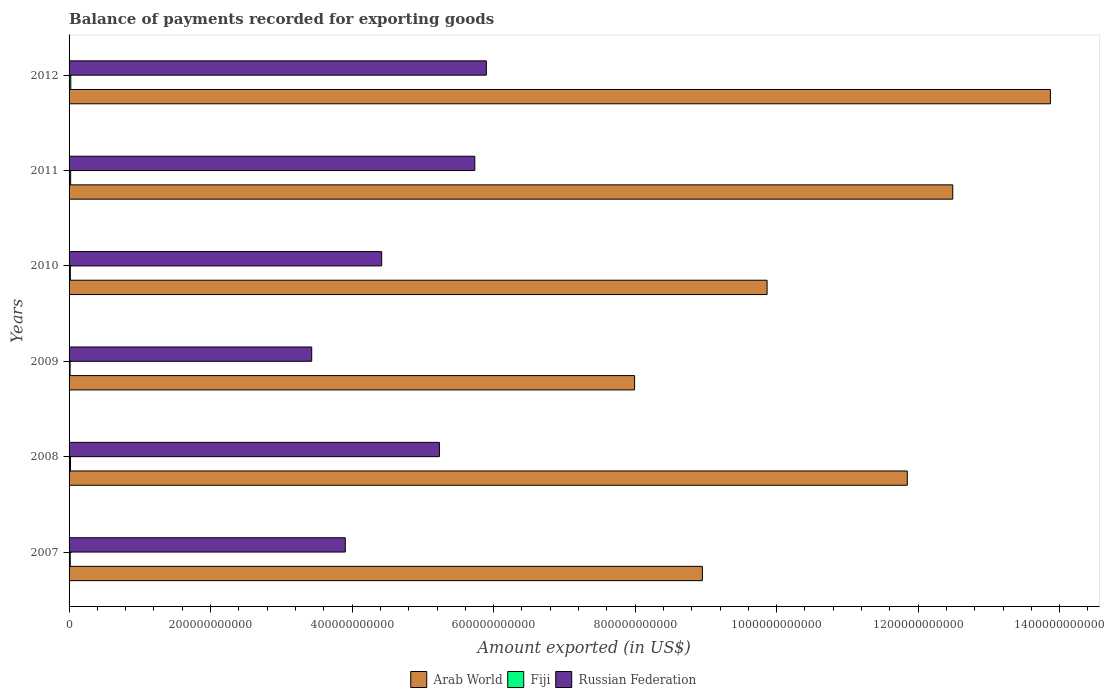How many different coloured bars are there?
Ensure brevity in your answer.  3. How many bars are there on the 5th tick from the bottom?
Offer a very short reply. 3. What is the label of the 2nd group of bars from the top?
Give a very brief answer. 2011. What is the amount exported in Russian Federation in 2011?
Ensure brevity in your answer.  5.73e+11. Across all years, what is the maximum amount exported in Arab World?
Your answer should be compact. 1.39e+12. Across all years, what is the minimum amount exported in Russian Federation?
Offer a very short reply. 3.43e+11. What is the total amount exported in Arab World in the graph?
Offer a terse response. 6.50e+12. What is the difference between the amount exported in Arab World in 2008 and that in 2010?
Your answer should be very brief. 1.98e+11. What is the difference between the amount exported in Fiji in 2011 and the amount exported in Russian Federation in 2008?
Make the answer very short. -5.21e+11. What is the average amount exported in Arab World per year?
Your answer should be very brief. 1.08e+12. In the year 2010, what is the difference between the amount exported in Arab World and amount exported in Russian Federation?
Your answer should be very brief. 5.45e+11. In how many years, is the amount exported in Fiji greater than 280000000000 US$?
Your answer should be very brief. 0. What is the ratio of the amount exported in Arab World in 2009 to that in 2010?
Provide a succinct answer. 0.81. Is the amount exported in Fiji in 2007 less than that in 2010?
Your answer should be very brief. Yes. What is the difference between the highest and the second highest amount exported in Fiji?
Offer a terse response. 2.04e+08. What is the difference between the highest and the lowest amount exported in Russian Federation?
Provide a succinct answer. 2.47e+11. Is the sum of the amount exported in Arab World in 2009 and 2012 greater than the maximum amount exported in Russian Federation across all years?
Provide a short and direct response. Yes. What does the 1st bar from the top in 2011 represents?
Your response must be concise. Russian Federation. What does the 3rd bar from the bottom in 2010 represents?
Your response must be concise. Russian Federation. Are all the bars in the graph horizontal?
Your response must be concise. Yes. How many years are there in the graph?
Give a very brief answer. 6. What is the difference between two consecutive major ticks on the X-axis?
Your answer should be compact. 2.00e+11. Are the values on the major ticks of X-axis written in scientific E-notation?
Make the answer very short. No. What is the title of the graph?
Offer a terse response. Balance of payments recorded for exporting goods. What is the label or title of the X-axis?
Provide a short and direct response. Amount exported (in US$). What is the Amount exported (in US$) in Arab World in 2007?
Offer a terse response. 8.95e+11. What is the Amount exported (in US$) of Fiji in 2007?
Provide a short and direct response. 1.65e+09. What is the Amount exported (in US$) in Russian Federation in 2007?
Ensure brevity in your answer.  3.90e+11. What is the Amount exported (in US$) in Arab World in 2008?
Provide a short and direct response. 1.18e+12. What is the Amount exported (in US$) of Fiji in 2008?
Provide a short and direct response. 2.02e+09. What is the Amount exported (in US$) in Russian Federation in 2008?
Keep it short and to the point. 5.23e+11. What is the Amount exported (in US$) of Arab World in 2009?
Ensure brevity in your answer.  7.99e+11. What is the Amount exported (in US$) in Fiji in 2009?
Your answer should be very brief. 1.42e+09. What is the Amount exported (in US$) of Russian Federation in 2009?
Give a very brief answer. 3.43e+11. What is the Amount exported (in US$) in Arab World in 2010?
Ensure brevity in your answer.  9.87e+11. What is the Amount exported (in US$) of Fiji in 2010?
Keep it short and to the point. 1.82e+09. What is the Amount exported (in US$) in Russian Federation in 2010?
Provide a succinct answer. 4.42e+11. What is the Amount exported (in US$) of Arab World in 2011?
Your response must be concise. 1.25e+12. What is the Amount exported (in US$) of Fiji in 2011?
Your answer should be very brief. 2.23e+09. What is the Amount exported (in US$) of Russian Federation in 2011?
Offer a terse response. 5.73e+11. What is the Amount exported (in US$) in Arab World in 2012?
Make the answer very short. 1.39e+12. What is the Amount exported (in US$) in Fiji in 2012?
Ensure brevity in your answer.  2.44e+09. What is the Amount exported (in US$) in Russian Federation in 2012?
Offer a terse response. 5.90e+11. Across all years, what is the maximum Amount exported (in US$) in Arab World?
Give a very brief answer. 1.39e+12. Across all years, what is the maximum Amount exported (in US$) in Fiji?
Your answer should be very brief. 2.44e+09. Across all years, what is the maximum Amount exported (in US$) in Russian Federation?
Your response must be concise. 5.90e+11. Across all years, what is the minimum Amount exported (in US$) of Arab World?
Give a very brief answer. 7.99e+11. Across all years, what is the minimum Amount exported (in US$) in Fiji?
Your answer should be compact. 1.42e+09. Across all years, what is the minimum Amount exported (in US$) in Russian Federation?
Keep it short and to the point. 3.43e+11. What is the total Amount exported (in US$) of Arab World in the graph?
Offer a very short reply. 6.50e+12. What is the total Amount exported (in US$) of Fiji in the graph?
Make the answer very short. 1.16e+1. What is the total Amount exported (in US$) in Russian Federation in the graph?
Keep it short and to the point. 2.86e+12. What is the difference between the Amount exported (in US$) of Arab World in 2007 and that in 2008?
Offer a very short reply. -2.90e+11. What is the difference between the Amount exported (in US$) in Fiji in 2007 and that in 2008?
Give a very brief answer. -3.68e+08. What is the difference between the Amount exported (in US$) of Russian Federation in 2007 and that in 2008?
Provide a succinct answer. -1.33e+11. What is the difference between the Amount exported (in US$) in Arab World in 2007 and that in 2009?
Offer a terse response. 9.59e+1. What is the difference between the Amount exported (in US$) of Fiji in 2007 and that in 2009?
Make the answer very short. 2.28e+08. What is the difference between the Amount exported (in US$) in Russian Federation in 2007 and that in 2009?
Offer a terse response. 4.74e+1. What is the difference between the Amount exported (in US$) of Arab World in 2007 and that in 2010?
Ensure brevity in your answer.  -9.14e+1. What is the difference between the Amount exported (in US$) of Fiji in 2007 and that in 2010?
Give a very brief answer. -1.70e+08. What is the difference between the Amount exported (in US$) of Russian Federation in 2007 and that in 2010?
Your answer should be very brief. -5.14e+1. What is the difference between the Amount exported (in US$) of Arab World in 2007 and that in 2011?
Provide a short and direct response. -3.54e+11. What is the difference between the Amount exported (in US$) of Fiji in 2007 and that in 2011?
Give a very brief answer. -5.82e+08. What is the difference between the Amount exported (in US$) in Russian Federation in 2007 and that in 2011?
Your answer should be very brief. -1.83e+11. What is the difference between the Amount exported (in US$) in Arab World in 2007 and that in 2012?
Provide a succinct answer. -4.92e+11. What is the difference between the Amount exported (in US$) in Fiji in 2007 and that in 2012?
Give a very brief answer. -7.86e+08. What is the difference between the Amount exported (in US$) in Russian Federation in 2007 and that in 2012?
Give a very brief answer. -1.99e+11. What is the difference between the Amount exported (in US$) of Arab World in 2008 and that in 2009?
Your response must be concise. 3.85e+11. What is the difference between the Amount exported (in US$) of Fiji in 2008 and that in 2009?
Your answer should be compact. 5.96e+08. What is the difference between the Amount exported (in US$) in Russian Federation in 2008 and that in 2009?
Keep it short and to the point. 1.80e+11. What is the difference between the Amount exported (in US$) of Arab World in 2008 and that in 2010?
Give a very brief answer. 1.98e+11. What is the difference between the Amount exported (in US$) in Fiji in 2008 and that in 2010?
Your answer should be very brief. 1.98e+08. What is the difference between the Amount exported (in US$) in Russian Federation in 2008 and that in 2010?
Provide a short and direct response. 8.16e+1. What is the difference between the Amount exported (in US$) in Arab World in 2008 and that in 2011?
Your response must be concise. -6.42e+1. What is the difference between the Amount exported (in US$) of Fiji in 2008 and that in 2011?
Give a very brief answer. -2.14e+08. What is the difference between the Amount exported (in US$) in Russian Federation in 2008 and that in 2011?
Your response must be concise. -5.00e+1. What is the difference between the Amount exported (in US$) in Arab World in 2008 and that in 2012?
Your answer should be compact. -2.02e+11. What is the difference between the Amount exported (in US$) in Fiji in 2008 and that in 2012?
Give a very brief answer. -4.18e+08. What is the difference between the Amount exported (in US$) of Russian Federation in 2008 and that in 2012?
Your response must be concise. -6.63e+1. What is the difference between the Amount exported (in US$) in Arab World in 2009 and that in 2010?
Your response must be concise. -1.87e+11. What is the difference between the Amount exported (in US$) of Fiji in 2009 and that in 2010?
Ensure brevity in your answer.  -3.98e+08. What is the difference between the Amount exported (in US$) of Russian Federation in 2009 and that in 2010?
Give a very brief answer. -9.89e+1. What is the difference between the Amount exported (in US$) in Arab World in 2009 and that in 2011?
Give a very brief answer. -4.50e+11. What is the difference between the Amount exported (in US$) of Fiji in 2009 and that in 2011?
Make the answer very short. -8.10e+08. What is the difference between the Amount exported (in US$) of Russian Federation in 2009 and that in 2011?
Your response must be concise. -2.30e+11. What is the difference between the Amount exported (in US$) in Arab World in 2009 and that in 2012?
Your answer should be very brief. -5.88e+11. What is the difference between the Amount exported (in US$) of Fiji in 2009 and that in 2012?
Offer a very short reply. -1.01e+09. What is the difference between the Amount exported (in US$) of Russian Federation in 2009 and that in 2012?
Keep it short and to the point. -2.47e+11. What is the difference between the Amount exported (in US$) of Arab World in 2010 and that in 2011?
Your answer should be compact. -2.62e+11. What is the difference between the Amount exported (in US$) in Fiji in 2010 and that in 2011?
Ensure brevity in your answer.  -4.11e+08. What is the difference between the Amount exported (in US$) of Russian Federation in 2010 and that in 2011?
Keep it short and to the point. -1.32e+11. What is the difference between the Amount exported (in US$) in Arab World in 2010 and that in 2012?
Your answer should be very brief. -4.00e+11. What is the difference between the Amount exported (in US$) of Fiji in 2010 and that in 2012?
Provide a succinct answer. -6.15e+08. What is the difference between the Amount exported (in US$) in Russian Federation in 2010 and that in 2012?
Offer a terse response. -1.48e+11. What is the difference between the Amount exported (in US$) in Arab World in 2011 and that in 2012?
Offer a very short reply. -1.38e+11. What is the difference between the Amount exported (in US$) in Fiji in 2011 and that in 2012?
Provide a short and direct response. -2.04e+08. What is the difference between the Amount exported (in US$) in Russian Federation in 2011 and that in 2012?
Provide a short and direct response. -1.63e+1. What is the difference between the Amount exported (in US$) of Arab World in 2007 and the Amount exported (in US$) of Fiji in 2008?
Your answer should be very brief. 8.93e+11. What is the difference between the Amount exported (in US$) of Arab World in 2007 and the Amount exported (in US$) of Russian Federation in 2008?
Make the answer very short. 3.72e+11. What is the difference between the Amount exported (in US$) in Fiji in 2007 and the Amount exported (in US$) in Russian Federation in 2008?
Offer a very short reply. -5.22e+11. What is the difference between the Amount exported (in US$) in Arab World in 2007 and the Amount exported (in US$) in Fiji in 2009?
Your response must be concise. 8.94e+11. What is the difference between the Amount exported (in US$) in Arab World in 2007 and the Amount exported (in US$) in Russian Federation in 2009?
Provide a succinct answer. 5.52e+11. What is the difference between the Amount exported (in US$) of Fiji in 2007 and the Amount exported (in US$) of Russian Federation in 2009?
Make the answer very short. -3.41e+11. What is the difference between the Amount exported (in US$) of Arab World in 2007 and the Amount exported (in US$) of Fiji in 2010?
Keep it short and to the point. 8.93e+11. What is the difference between the Amount exported (in US$) in Arab World in 2007 and the Amount exported (in US$) in Russian Federation in 2010?
Ensure brevity in your answer.  4.53e+11. What is the difference between the Amount exported (in US$) in Fiji in 2007 and the Amount exported (in US$) in Russian Federation in 2010?
Your response must be concise. -4.40e+11. What is the difference between the Amount exported (in US$) of Arab World in 2007 and the Amount exported (in US$) of Fiji in 2011?
Your response must be concise. 8.93e+11. What is the difference between the Amount exported (in US$) in Arab World in 2007 and the Amount exported (in US$) in Russian Federation in 2011?
Provide a succinct answer. 3.22e+11. What is the difference between the Amount exported (in US$) in Fiji in 2007 and the Amount exported (in US$) in Russian Federation in 2011?
Make the answer very short. -5.72e+11. What is the difference between the Amount exported (in US$) of Arab World in 2007 and the Amount exported (in US$) of Fiji in 2012?
Provide a short and direct response. 8.93e+11. What is the difference between the Amount exported (in US$) in Arab World in 2007 and the Amount exported (in US$) in Russian Federation in 2012?
Offer a terse response. 3.05e+11. What is the difference between the Amount exported (in US$) in Fiji in 2007 and the Amount exported (in US$) in Russian Federation in 2012?
Offer a very short reply. -5.88e+11. What is the difference between the Amount exported (in US$) of Arab World in 2008 and the Amount exported (in US$) of Fiji in 2009?
Make the answer very short. 1.18e+12. What is the difference between the Amount exported (in US$) of Arab World in 2008 and the Amount exported (in US$) of Russian Federation in 2009?
Provide a short and direct response. 8.42e+11. What is the difference between the Amount exported (in US$) of Fiji in 2008 and the Amount exported (in US$) of Russian Federation in 2009?
Provide a short and direct response. -3.41e+11. What is the difference between the Amount exported (in US$) of Arab World in 2008 and the Amount exported (in US$) of Fiji in 2010?
Your answer should be compact. 1.18e+12. What is the difference between the Amount exported (in US$) in Arab World in 2008 and the Amount exported (in US$) in Russian Federation in 2010?
Ensure brevity in your answer.  7.43e+11. What is the difference between the Amount exported (in US$) of Fiji in 2008 and the Amount exported (in US$) of Russian Federation in 2010?
Your answer should be compact. -4.40e+11. What is the difference between the Amount exported (in US$) in Arab World in 2008 and the Amount exported (in US$) in Fiji in 2011?
Make the answer very short. 1.18e+12. What is the difference between the Amount exported (in US$) in Arab World in 2008 and the Amount exported (in US$) in Russian Federation in 2011?
Offer a very short reply. 6.11e+11. What is the difference between the Amount exported (in US$) in Fiji in 2008 and the Amount exported (in US$) in Russian Federation in 2011?
Ensure brevity in your answer.  -5.71e+11. What is the difference between the Amount exported (in US$) of Arab World in 2008 and the Amount exported (in US$) of Fiji in 2012?
Your answer should be compact. 1.18e+12. What is the difference between the Amount exported (in US$) in Arab World in 2008 and the Amount exported (in US$) in Russian Federation in 2012?
Keep it short and to the point. 5.95e+11. What is the difference between the Amount exported (in US$) in Fiji in 2008 and the Amount exported (in US$) in Russian Federation in 2012?
Offer a very short reply. -5.88e+11. What is the difference between the Amount exported (in US$) in Arab World in 2009 and the Amount exported (in US$) in Fiji in 2010?
Offer a terse response. 7.97e+11. What is the difference between the Amount exported (in US$) of Arab World in 2009 and the Amount exported (in US$) of Russian Federation in 2010?
Give a very brief answer. 3.57e+11. What is the difference between the Amount exported (in US$) of Fiji in 2009 and the Amount exported (in US$) of Russian Federation in 2010?
Give a very brief answer. -4.40e+11. What is the difference between the Amount exported (in US$) of Arab World in 2009 and the Amount exported (in US$) of Fiji in 2011?
Your response must be concise. 7.97e+11. What is the difference between the Amount exported (in US$) in Arab World in 2009 and the Amount exported (in US$) in Russian Federation in 2011?
Your answer should be compact. 2.26e+11. What is the difference between the Amount exported (in US$) in Fiji in 2009 and the Amount exported (in US$) in Russian Federation in 2011?
Keep it short and to the point. -5.72e+11. What is the difference between the Amount exported (in US$) in Arab World in 2009 and the Amount exported (in US$) in Fiji in 2012?
Make the answer very short. 7.97e+11. What is the difference between the Amount exported (in US$) of Arab World in 2009 and the Amount exported (in US$) of Russian Federation in 2012?
Give a very brief answer. 2.09e+11. What is the difference between the Amount exported (in US$) in Fiji in 2009 and the Amount exported (in US$) in Russian Federation in 2012?
Your response must be concise. -5.88e+11. What is the difference between the Amount exported (in US$) in Arab World in 2010 and the Amount exported (in US$) in Fiji in 2011?
Offer a very short reply. 9.84e+11. What is the difference between the Amount exported (in US$) of Arab World in 2010 and the Amount exported (in US$) of Russian Federation in 2011?
Your response must be concise. 4.13e+11. What is the difference between the Amount exported (in US$) of Fiji in 2010 and the Amount exported (in US$) of Russian Federation in 2011?
Make the answer very short. -5.72e+11. What is the difference between the Amount exported (in US$) of Arab World in 2010 and the Amount exported (in US$) of Fiji in 2012?
Make the answer very short. 9.84e+11. What is the difference between the Amount exported (in US$) in Arab World in 2010 and the Amount exported (in US$) in Russian Federation in 2012?
Offer a very short reply. 3.97e+11. What is the difference between the Amount exported (in US$) of Fiji in 2010 and the Amount exported (in US$) of Russian Federation in 2012?
Keep it short and to the point. -5.88e+11. What is the difference between the Amount exported (in US$) of Arab World in 2011 and the Amount exported (in US$) of Fiji in 2012?
Your answer should be compact. 1.25e+12. What is the difference between the Amount exported (in US$) of Arab World in 2011 and the Amount exported (in US$) of Russian Federation in 2012?
Offer a terse response. 6.59e+11. What is the difference between the Amount exported (in US$) of Fiji in 2011 and the Amount exported (in US$) of Russian Federation in 2012?
Your answer should be compact. -5.88e+11. What is the average Amount exported (in US$) in Arab World per year?
Offer a very short reply. 1.08e+12. What is the average Amount exported (in US$) in Fiji per year?
Keep it short and to the point. 1.93e+09. What is the average Amount exported (in US$) of Russian Federation per year?
Provide a succinct answer. 4.77e+11. In the year 2007, what is the difference between the Amount exported (in US$) in Arab World and Amount exported (in US$) in Fiji?
Your answer should be very brief. 8.93e+11. In the year 2007, what is the difference between the Amount exported (in US$) in Arab World and Amount exported (in US$) in Russian Federation?
Your answer should be compact. 5.05e+11. In the year 2007, what is the difference between the Amount exported (in US$) of Fiji and Amount exported (in US$) of Russian Federation?
Provide a short and direct response. -3.89e+11. In the year 2008, what is the difference between the Amount exported (in US$) in Arab World and Amount exported (in US$) in Fiji?
Make the answer very short. 1.18e+12. In the year 2008, what is the difference between the Amount exported (in US$) in Arab World and Amount exported (in US$) in Russian Federation?
Provide a short and direct response. 6.61e+11. In the year 2008, what is the difference between the Amount exported (in US$) of Fiji and Amount exported (in US$) of Russian Federation?
Provide a succinct answer. -5.21e+11. In the year 2009, what is the difference between the Amount exported (in US$) of Arab World and Amount exported (in US$) of Fiji?
Offer a very short reply. 7.98e+11. In the year 2009, what is the difference between the Amount exported (in US$) in Arab World and Amount exported (in US$) in Russian Federation?
Offer a terse response. 4.56e+11. In the year 2009, what is the difference between the Amount exported (in US$) of Fiji and Amount exported (in US$) of Russian Federation?
Offer a terse response. -3.42e+11. In the year 2010, what is the difference between the Amount exported (in US$) of Arab World and Amount exported (in US$) of Fiji?
Keep it short and to the point. 9.85e+11. In the year 2010, what is the difference between the Amount exported (in US$) of Arab World and Amount exported (in US$) of Russian Federation?
Your response must be concise. 5.45e+11. In the year 2010, what is the difference between the Amount exported (in US$) in Fiji and Amount exported (in US$) in Russian Federation?
Offer a terse response. -4.40e+11. In the year 2011, what is the difference between the Amount exported (in US$) in Arab World and Amount exported (in US$) in Fiji?
Give a very brief answer. 1.25e+12. In the year 2011, what is the difference between the Amount exported (in US$) of Arab World and Amount exported (in US$) of Russian Federation?
Ensure brevity in your answer.  6.75e+11. In the year 2011, what is the difference between the Amount exported (in US$) in Fiji and Amount exported (in US$) in Russian Federation?
Your answer should be very brief. -5.71e+11. In the year 2012, what is the difference between the Amount exported (in US$) of Arab World and Amount exported (in US$) of Fiji?
Ensure brevity in your answer.  1.38e+12. In the year 2012, what is the difference between the Amount exported (in US$) of Arab World and Amount exported (in US$) of Russian Federation?
Provide a short and direct response. 7.97e+11. In the year 2012, what is the difference between the Amount exported (in US$) in Fiji and Amount exported (in US$) in Russian Federation?
Give a very brief answer. -5.87e+11. What is the ratio of the Amount exported (in US$) of Arab World in 2007 to that in 2008?
Give a very brief answer. 0.76. What is the ratio of the Amount exported (in US$) of Fiji in 2007 to that in 2008?
Make the answer very short. 0.82. What is the ratio of the Amount exported (in US$) of Russian Federation in 2007 to that in 2008?
Your answer should be very brief. 0.75. What is the ratio of the Amount exported (in US$) in Arab World in 2007 to that in 2009?
Make the answer very short. 1.12. What is the ratio of the Amount exported (in US$) of Fiji in 2007 to that in 2009?
Keep it short and to the point. 1.16. What is the ratio of the Amount exported (in US$) of Russian Federation in 2007 to that in 2009?
Provide a succinct answer. 1.14. What is the ratio of the Amount exported (in US$) in Arab World in 2007 to that in 2010?
Offer a terse response. 0.91. What is the ratio of the Amount exported (in US$) in Fiji in 2007 to that in 2010?
Keep it short and to the point. 0.91. What is the ratio of the Amount exported (in US$) in Russian Federation in 2007 to that in 2010?
Make the answer very short. 0.88. What is the ratio of the Amount exported (in US$) in Arab World in 2007 to that in 2011?
Provide a short and direct response. 0.72. What is the ratio of the Amount exported (in US$) in Fiji in 2007 to that in 2011?
Give a very brief answer. 0.74. What is the ratio of the Amount exported (in US$) in Russian Federation in 2007 to that in 2011?
Offer a terse response. 0.68. What is the ratio of the Amount exported (in US$) of Arab World in 2007 to that in 2012?
Give a very brief answer. 0.65. What is the ratio of the Amount exported (in US$) in Fiji in 2007 to that in 2012?
Provide a short and direct response. 0.68. What is the ratio of the Amount exported (in US$) in Russian Federation in 2007 to that in 2012?
Provide a short and direct response. 0.66. What is the ratio of the Amount exported (in US$) of Arab World in 2008 to that in 2009?
Provide a succinct answer. 1.48. What is the ratio of the Amount exported (in US$) of Fiji in 2008 to that in 2009?
Provide a short and direct response. 1.42. What is the ratio of the Amount exported (in US$) in Russian Federation in 2008 to that in 2009?
Offer a terse response. 1.53. What is the ratio of the Amount exported (in US$) in Arab World in 2008 to that in 2010?
Keep it short and to the point. 1.2. What is the ratio of the Amount exported (in US$) of Fiji in 2008 to that in 2010?
Offer a very short reply. 1.11. What is the ratio of the Amount exported (in US$) of Russian Federation in 2008 to that in 2010?
Ensure brevity in your answer.  1.18. What is the ratio of the Amount exported (in US$) of Arab World in 2008 to that in 2011?
Your answer should be very brief. 0.95. What is the ratio of the Amount exported (in US$) of Fiji in 2008 to that in 2011?
Provide a short and direct response. 0.9. What is the ratio of the Amount exported (in US$) in Russian Federation in 2008 to that in 2011?
Ensure brevity in your answer.  0.91. What is the ratio of the Amount exported (in US$) in Arab World in 2008 to that in 2012?
Your response must be concise. 0.85. What is the ratio of the Amount exported (in US$) of Fiji in 2008 to that in 2012?
Your answer should be very brief. 0.83. What is the ratio of the Amount exported (in US$) of Russian Federation in 2008 to that in 2012?
Ensure brevity in your answer.  0.89. What is the ratio of the Amount exported (in US$) of Arab World in 2009 to that in 2010?
Your answer should be very brief. 0.81. What is the ratio of the Amount exported (in US$) of Fiji in 2009 to that in 2010?
Give a very brief answer. 0.78. What is the ratio of the Amount exported (in US$) in Russian Federation in 2009 to that in 2010?
Your response must be concise. 0.78. What is the ratio of the Amount exported (in US$) in Arab World in 2009 to that in 2011?
Provide a short and direct response. 0.64. What is the ratio of the Amount exported (in US$) of Fiji in 2009 to that in 2011?
Make the answer very short. 0.64. What is the ratio of the Amount exported (in US$) of Russian Federation in 2009 to that in 2011?
Offer a very short reply. 0.6. What is the ratio of the Amount exported (in US$) in Arab World in 2009 to that in 2012?
Keep it short and to the point. 0.58. What is the ratio of the Amount exported (in US$) in Fiji in 2009 to that in 2012?
Ensure brevity in your answer.  0.58. What is the ratio of the Amount exported (in US$) in Russian Federation in 2009 to that in 2012?
Your response must be concise. 0.58. What is the ratio of the Amount exported (in US$) in Arab World in 2010 to that in 2011?
Offer a terse response. 0.79. What is the ratio of the Amount exported (in US$) in Fiji in 2010 to that in 2011?
Your answer should be compact. 0.82. What is the ratio of the Amount exported (in US$) of Russian Federation in 2010 to that in 2011?
Make the answer very short. 0.77. What is the ratio of the Amount exported (in US$) of Arab World in 2010 to that in 2012?
Provide a succinct answer. 0.71. What is the ratio of the Amount exported (in US$) in Fiji in 2010 to that in 2012?
Your response must be concise. 0.75. What is the ratio of the Amount exported (in US$) in Russian Federation in 2010 to that in 2012?
Offer a terse response. 0.75. What is the ratio of the Amount exported (in US$) in Arab World in 2011 to that in 2012?
Your answer should be very brief. 0.9. What is the ratio of the Amount exported (in US$) in Fiji in 2011 to that in 2012?
Offer a very short reply. 0.92. What is the ratio of the Amount exported (in US$) in Russian Federation in 2011 to that in 2012?
Ensure brevity in your answer.  0.97. What is the difference between the highest and the second highest Amount exported (in US$) of Arab World?
Make the answer very short. 1.38e+11. What is the difference between the highest and the second highest Amount exported (in US$) in Fiji?
Your response must be concise. 2.04e+08. What is the difference between the highest and the second highest Amount exported (in US$) of Russian Federation?
Offer a very short reply. 1.63e+1. What is the difference between the highest and the lowest Amount exported (in US$) in Arab World?
Your answer should be compact. 5.88e+11. What is the difference between the highest and the lowest Amount exported (in US$) in Fiji?
Your response must be concise. 1.01e+09. What is the difference between the highest and the lowest Amount exported (in US$) of Russian Federation?
Offer a terse response. 2.47e+11. 